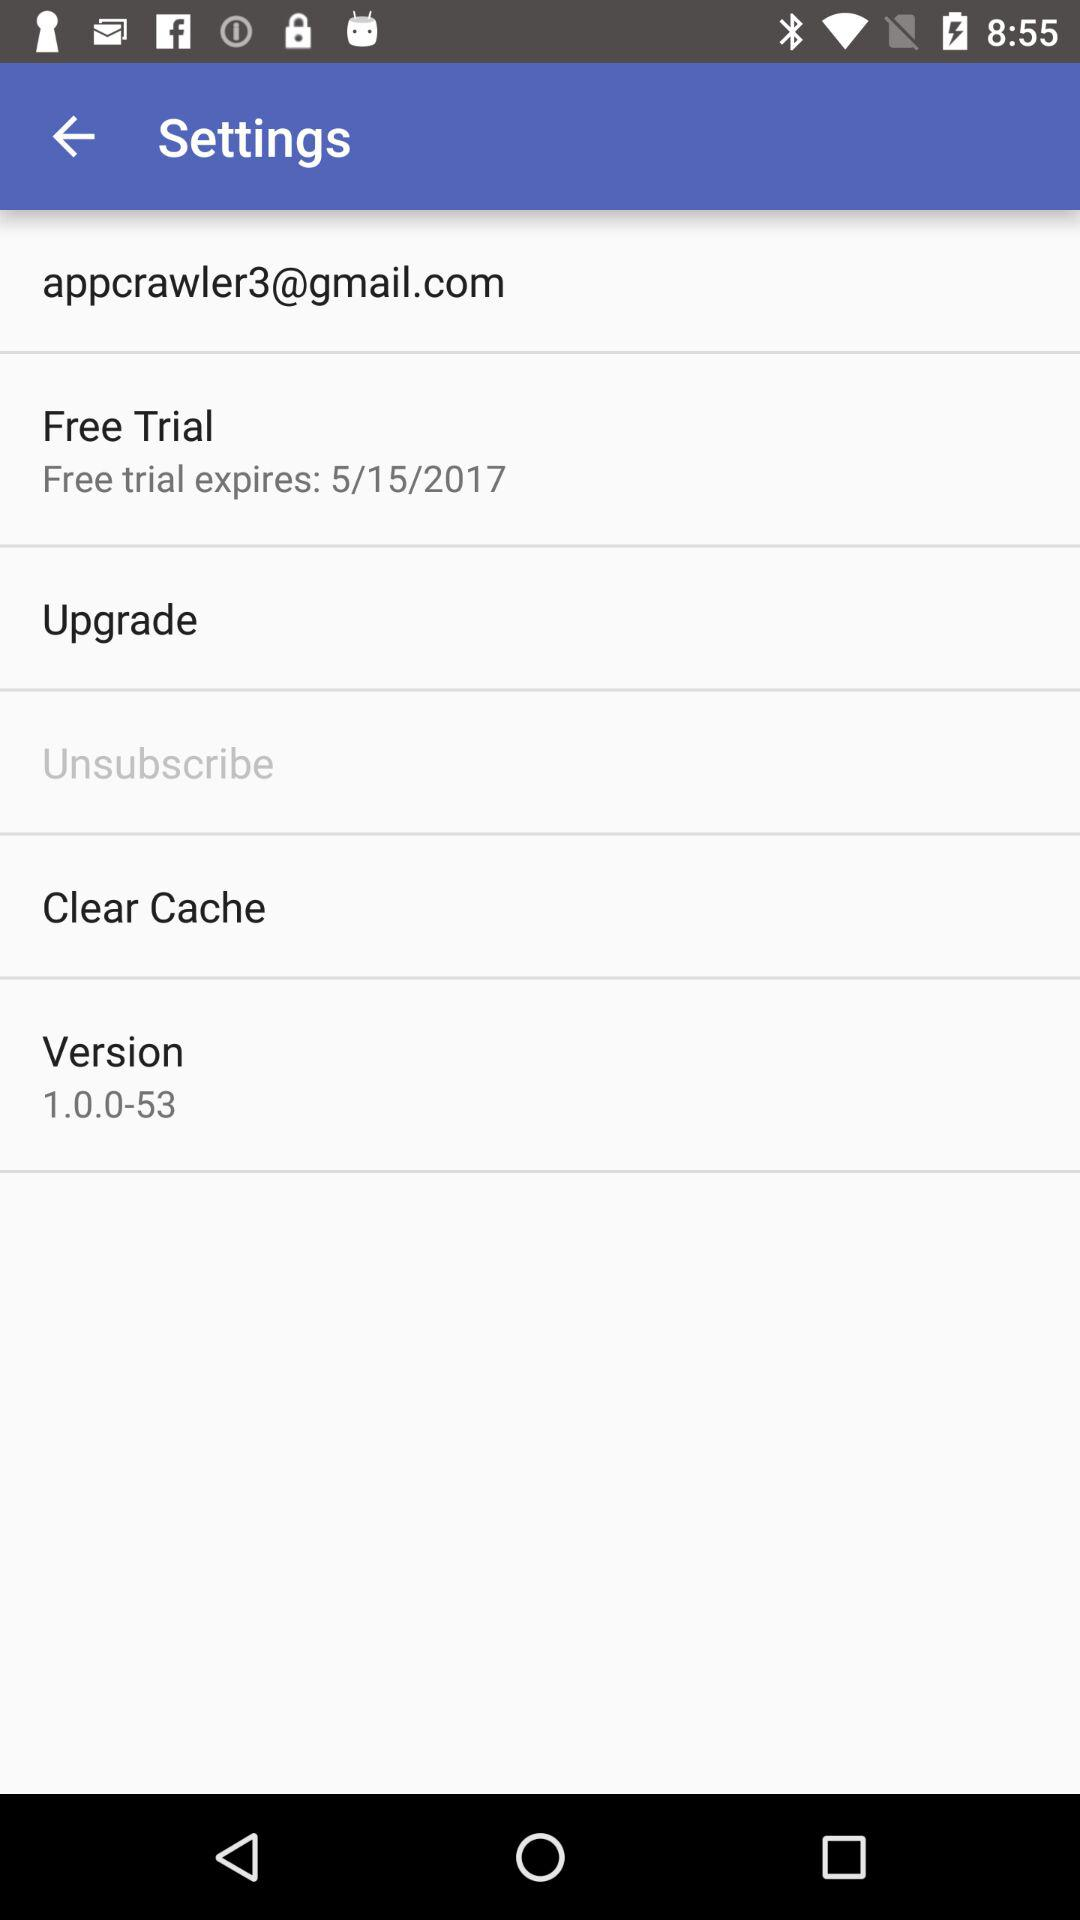Which version is used? The used version is 1.0.0-53. 